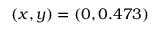Convert formula to latex. <formula><loc_0><loc_0><loc_500><loc_500>( x , y ) = ( 0 , 0 . 4 7 3 )</formula> 